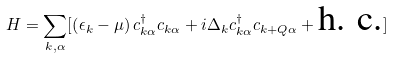Convert formula to latex. <formula><loc_0><loc_0><loc_500><loc_500>H = \sum _ { { k } , \alpha } [ \left ( \epsilon _ { k } - \mu \right ) c ^ { \dagger } _ { { k } \alpha } c _ { { k } \alpha } + i \Delta _ { k } c ^ { \dagger } _ { { k } \alpha } c _ { { k + Q } \alpha } + \text {h. c.} ]</formula> 